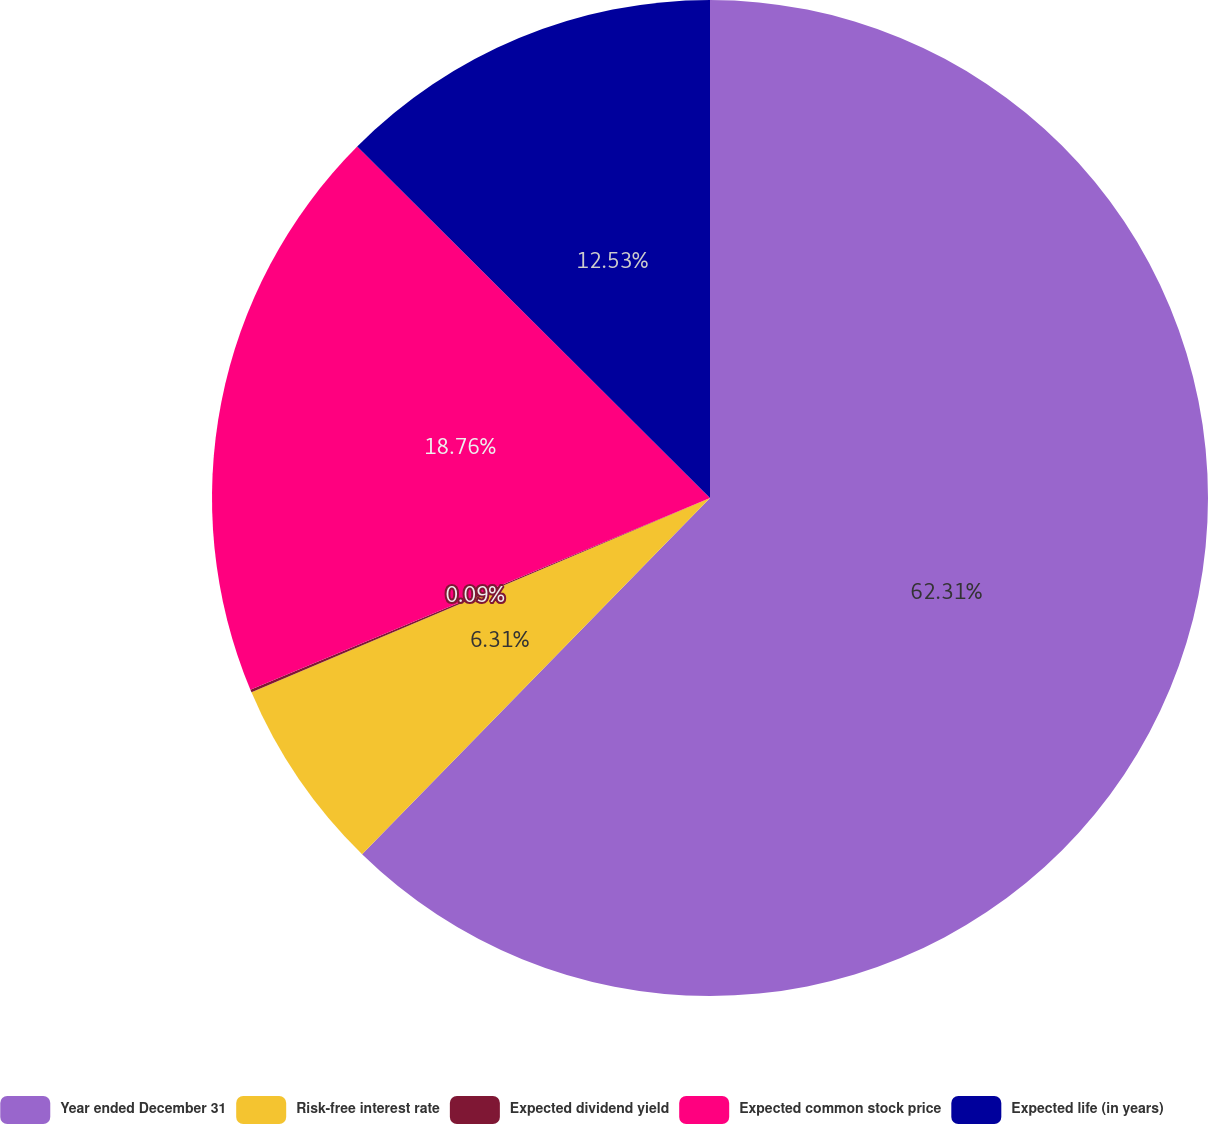Convert chart to OTSL. <chart><loc_0><loc_0><loc_500><loc_500><pie_chart><fcel>Year ended December 31<fcel>Risk-free interest rate<fcel>Expected dividend yield<fcel>Expected common stock price<fcel>Expected life (in years)<nl><fcel>62.31%<fcel>6.31%<fcel>0.09%<fcel>18.76%<fcel>12.53%<nl></chart> 